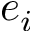Convert formula to latex. <formula><loc_0><loc_0><loc_500><loc_500>e _ { i }</formula> 